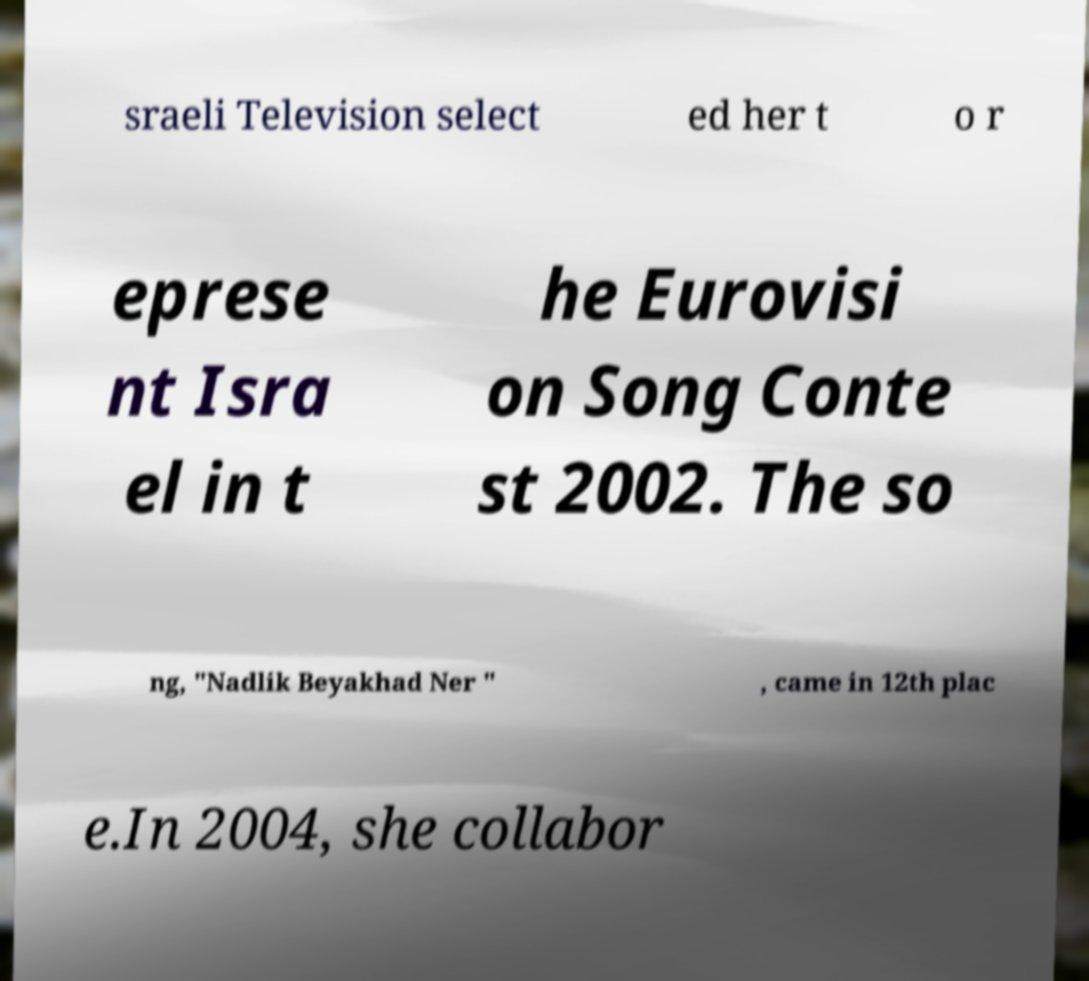Please read and relay the text visible in this image. What does it say? sraeli Television select ed her t o r eprese nt Isra el in t he Eurovisi on Song Conte st 2002. The so ng, "Nadlik Beyakhad Ner " , came in 12th plac e.In 2004, she collabor 